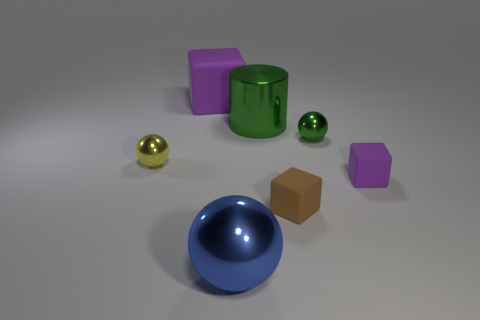Is there a small object of the same shape as the big purple thing?
Provide a short and direct response. Yes. There is a purple object that is behind the tiny rubber block behind the brown rubber block; what size is it?
Offer a terse response. Large. What shape is the brown thing that is in front of the small yellow metal ball left of the purple rubber block that is behind the large green cylinder?
Provide a short and direct response. Cube. What size is the green cylinder that is the same material as the blue object?
Offer a very short reply. Large. Is the number of tiny purple spheres greater than the number of large blue balls?
Your response must be concise. No. There is a yellow thing that is the same size as the brown object; what material is it?
Ensure brevity in your answer.  Metal. Is the size of the purple object that is on the right side of the blue shiny object the same as the blue metal sphere?
Your answer should be compact. No. What number of balls are either large brown things or yellow shiny things?
Keep it short and to the point. 1. What is the purple cube that is in front of the big cylinder made of?
Keep it short and to the point. Rubber. Are there fewer brown things than tiny red metallic cubes?
Ensure brevity in your answer.  No. 